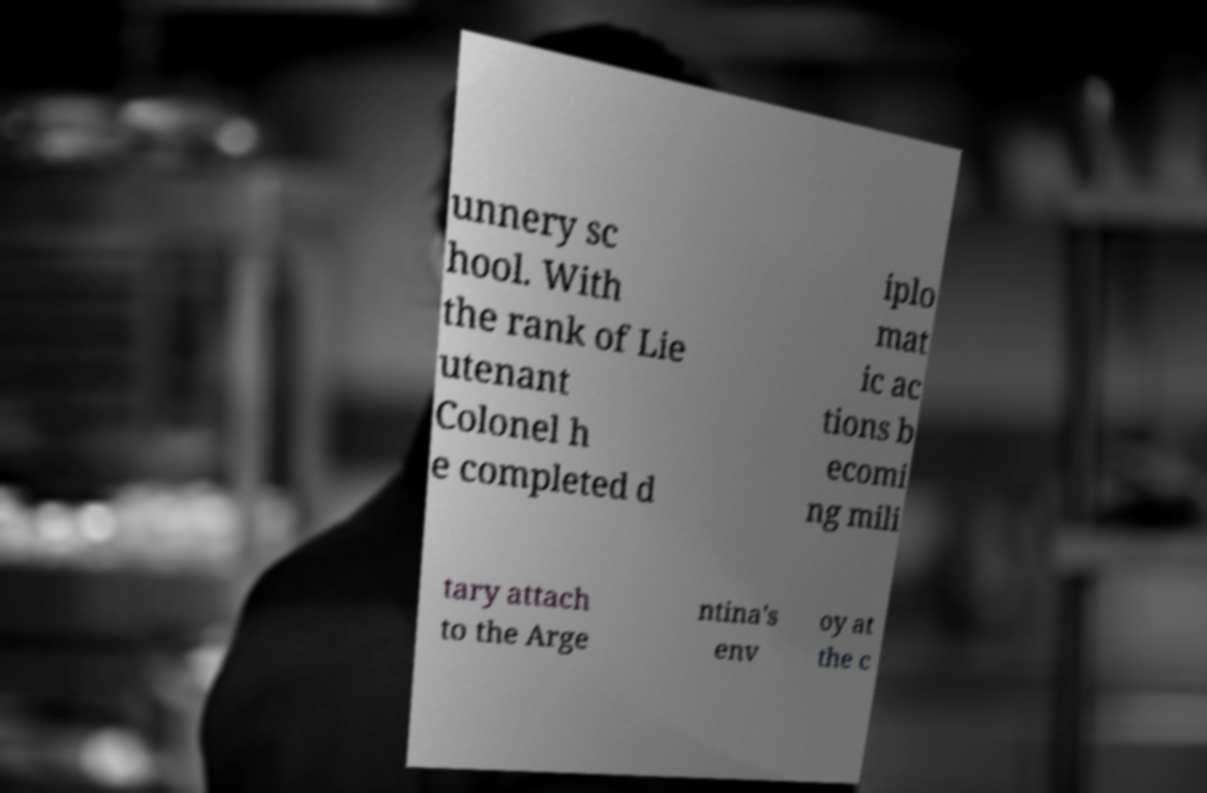There's text embedded in this image that I need extracted. Can you transcribe it verbatim? unnery sc hool. With the rank of Lie utenant Colonel h e completed d iplo mat ic ac tions b ecomi ng mili tary attach to the Arge ntina's env oy at the c 